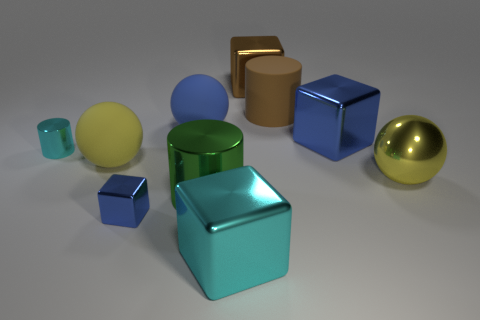What color is the tiny cylinder that is the same material as the large green cylinder? cyan 